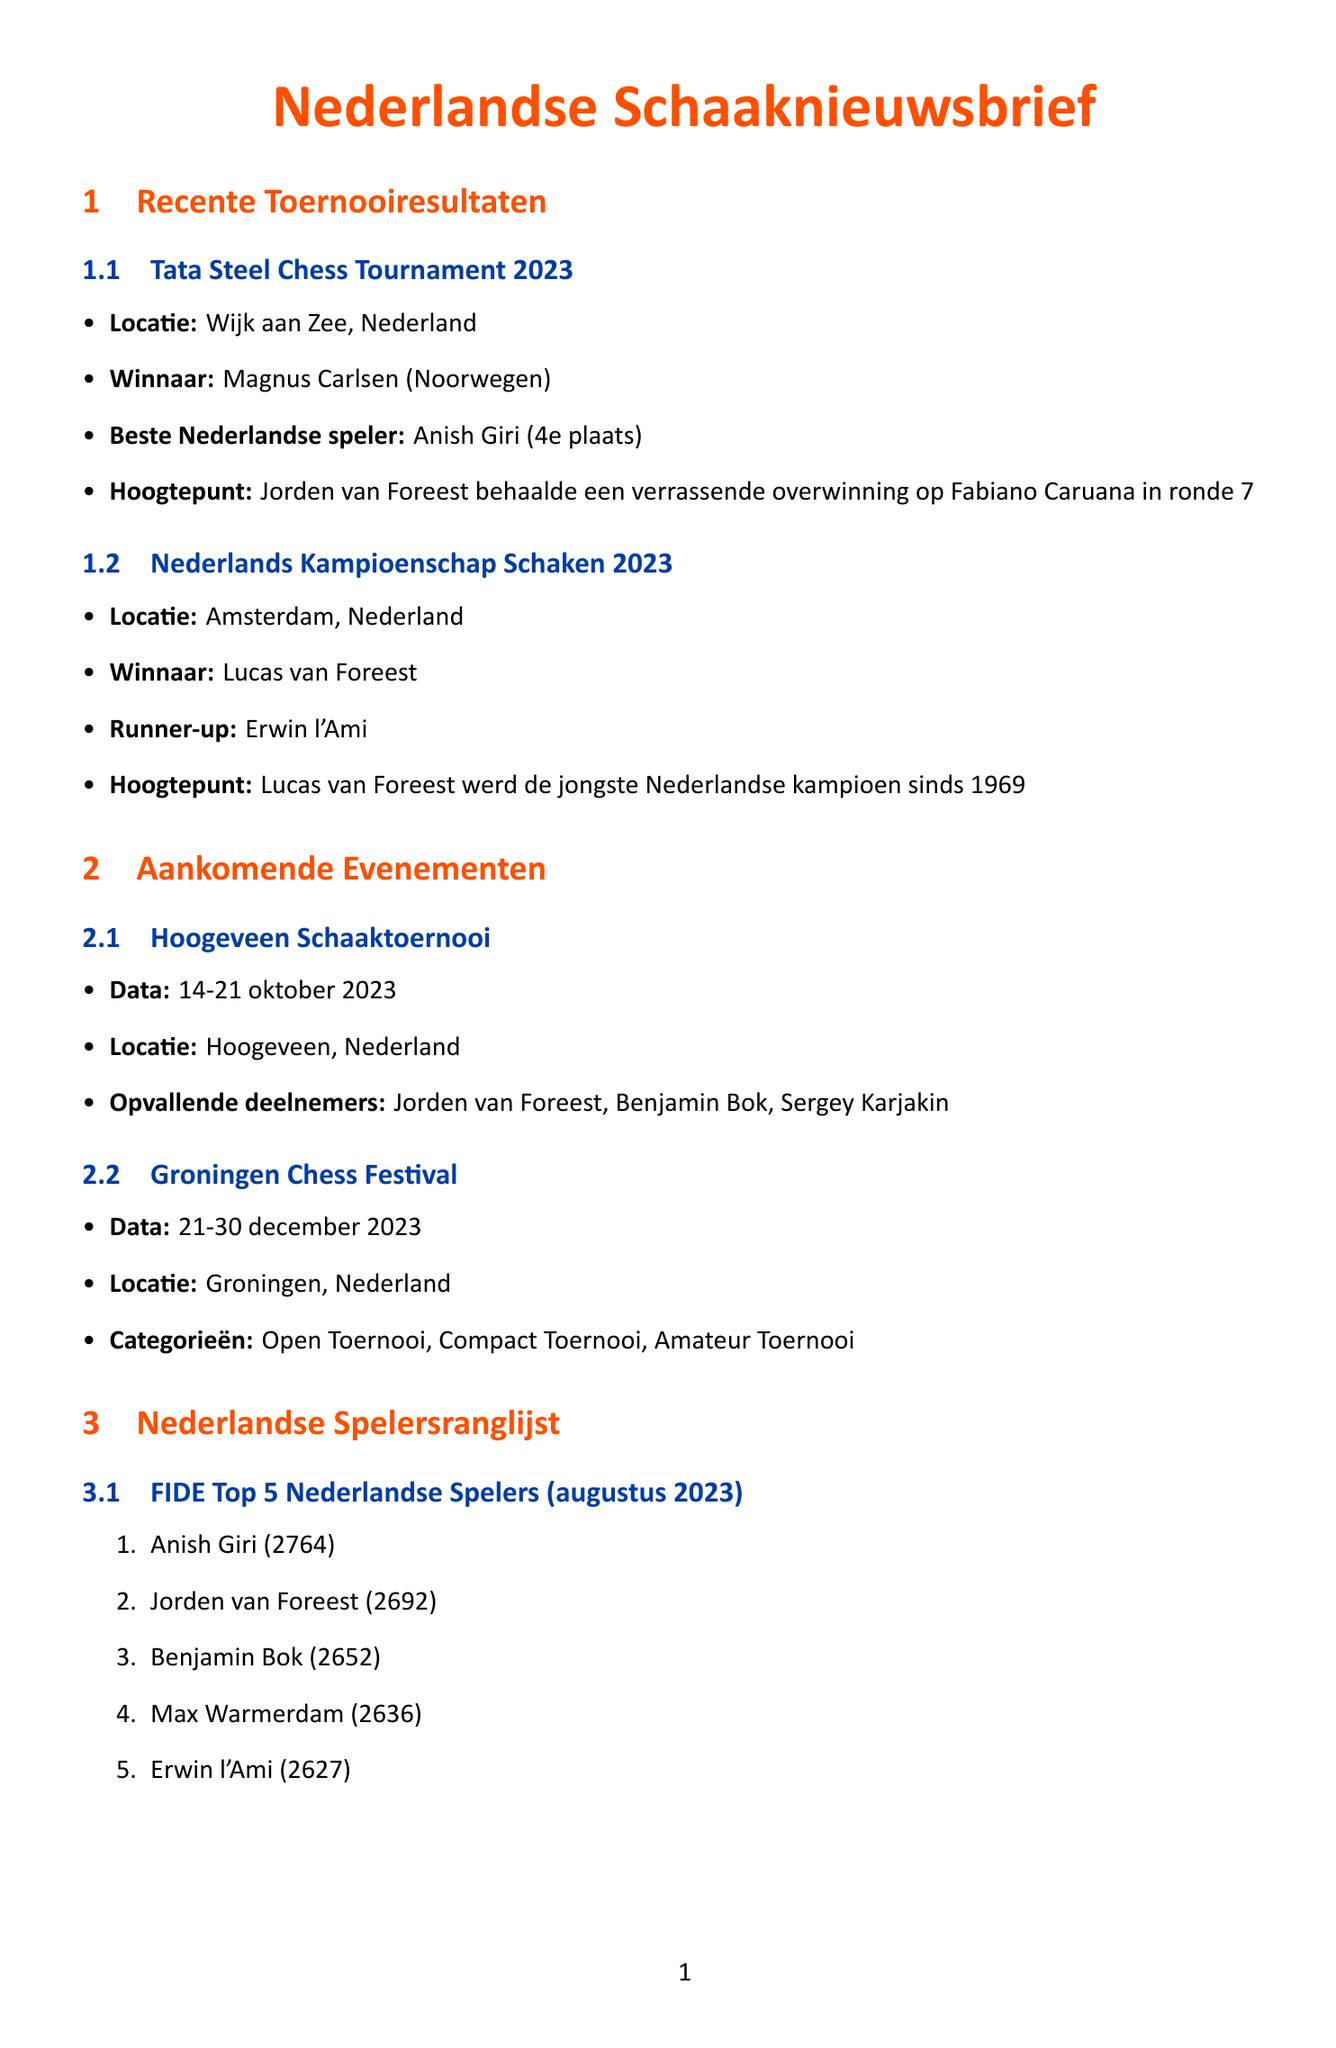What is the location of the Tata Steel Chess Tournament 2023? The location is mentioned in the results section of the document.
Answer: Wijk aan Zee, Netherlands Who won the Dutch Chess Championship 2023? The winner of the Dutch Chess Championship is stated clearly in the results section.
Answer: Lucas van Foreest What place did Anish Giri finish in the Tata Steel Chess Tournament 2023? The document specifies Anish Giri's placement among the participants in the tournament results section.
Answer: 4th place What are the dates for the Hoogeveen Chess Tournament? The dates are listed in the upcoming events section of the document.
Answer: October 14-21, 2023 Which player has the highest FIDE rating in the current Dutch rankings? The rankings section indicates the player with the highest rating among Dutch players.
Answer: Anish Giri What was highlighted as a match from the Dutch Chess Championship 2023? Specific matches are highlighted in the match highlights section of the document.
Answer: Lucas van Foreest vs. Erwin l'Ami How many categories are there in the Groningen Chess Festival? The number of categories is found in the details about the Groningen Chess Festival in the upcoming events section.
Answer: 3 categories Name one notable participant in the Hoogeveen Chess Tournament. Notable players are listed in the upcoming events section.
Answer: Jorden van Foreest What is the main focus of the new training program announced by the Dutch Chess Federation? The details about the training program provide insight into its target group.
Answer: Players under 16 